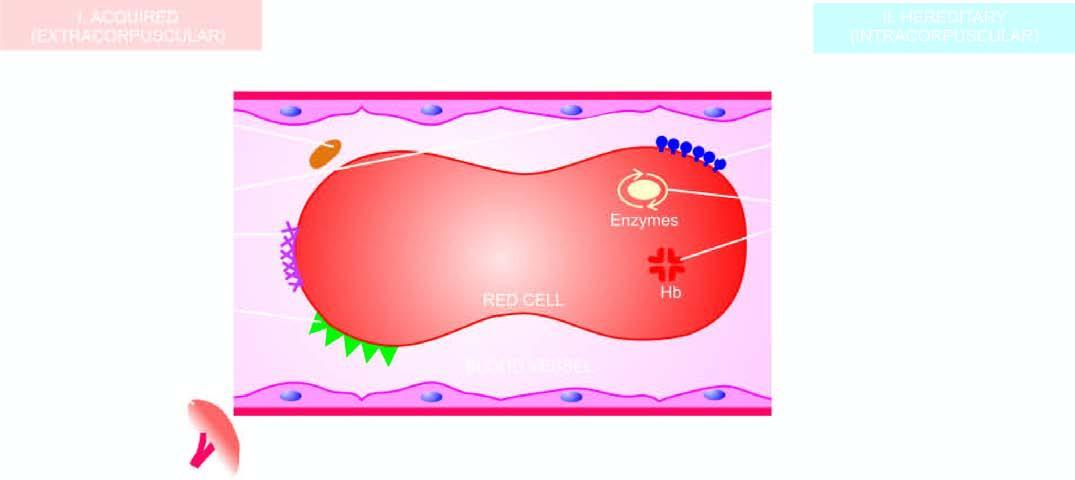s diagrammatic representation of classification of haemolytic anaemias based on principal mechanisms of haemolysis?
Answer the question using a single word or phrase. Yes 